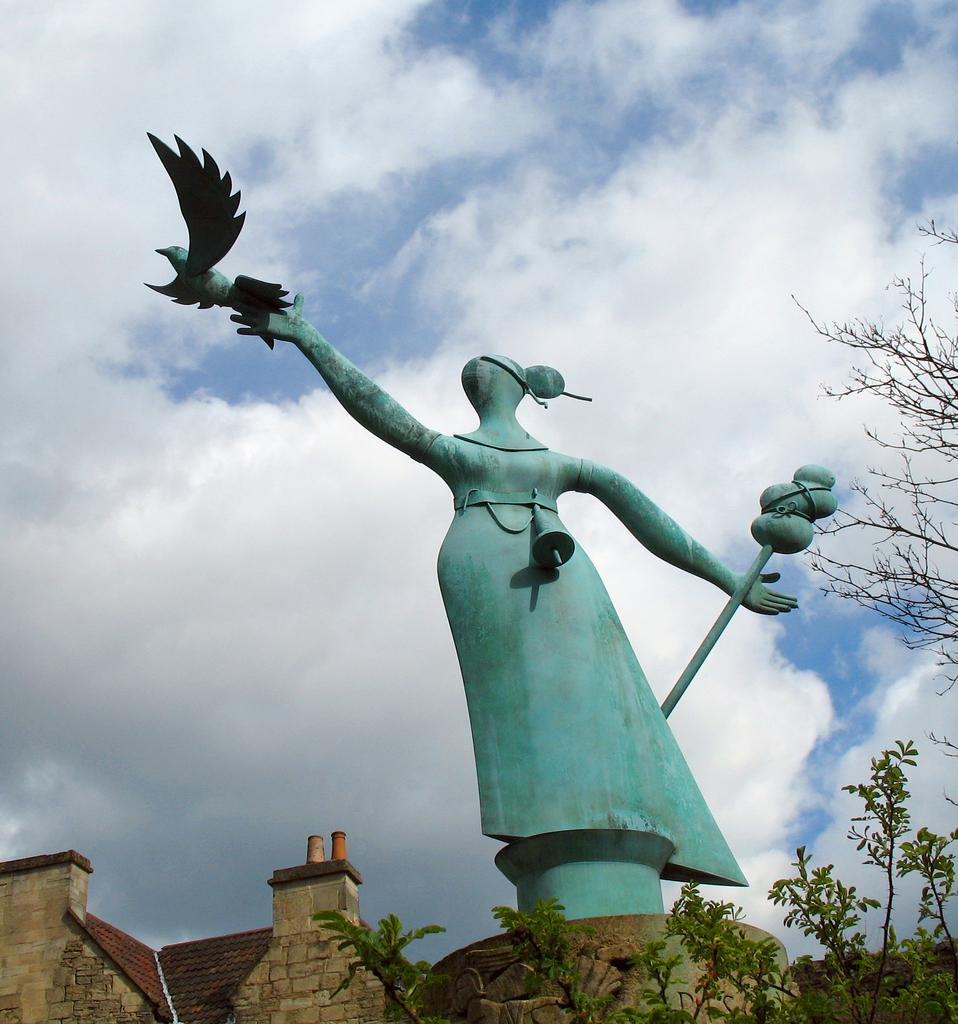What is the main subject in the image? There is a sculpture in the image. What other structures can be seen at the bottom of the image? There are buildings at the bottom of the image. What type of vegetation is visible in the image? Leaves are visible in the image. What is visible at the top of the image? The sky is visible at the top of the image. Where is the tree located in the image? There is a tree on the right side of the image. What type of grain is being harvested by the person on their knee in the image? There is no person or grain present in the image; it features a sculpture, buildings, leaves, and a tree. 